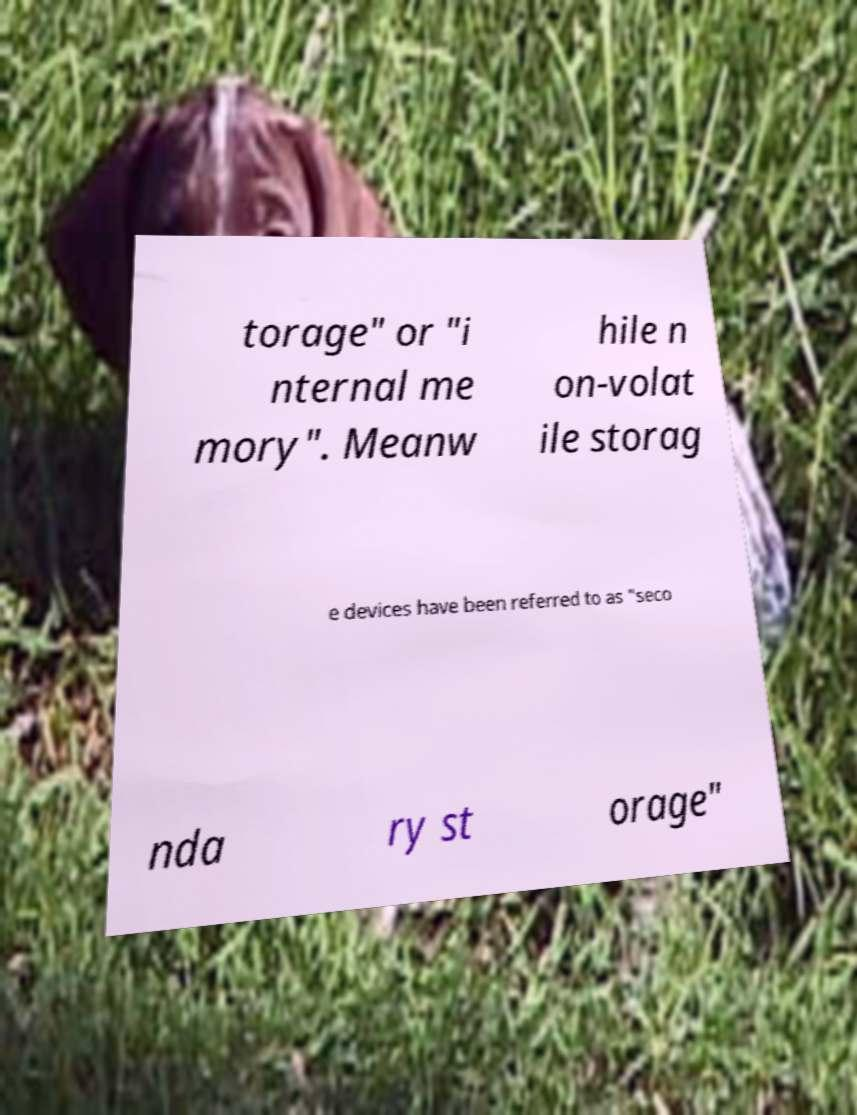What messages or text are displayed in this image? I need them in a readable, typed format. torage" or "i nternal me mory". Meanw hile n on-volat ile storag e devices have been referred to as "seco nda ry st orage" 